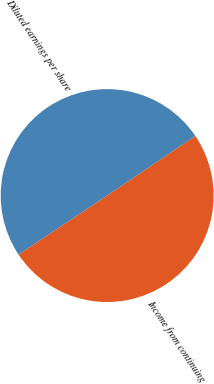Convert chart to OTSL. <chart><loc_0><loc_0><loc_500><loc_500><pie_chart><fcel>Income from continuing<fcel>Diluted earnings per share<nl><fcel>50.12%<fcel>49.88%<nl></chart> 